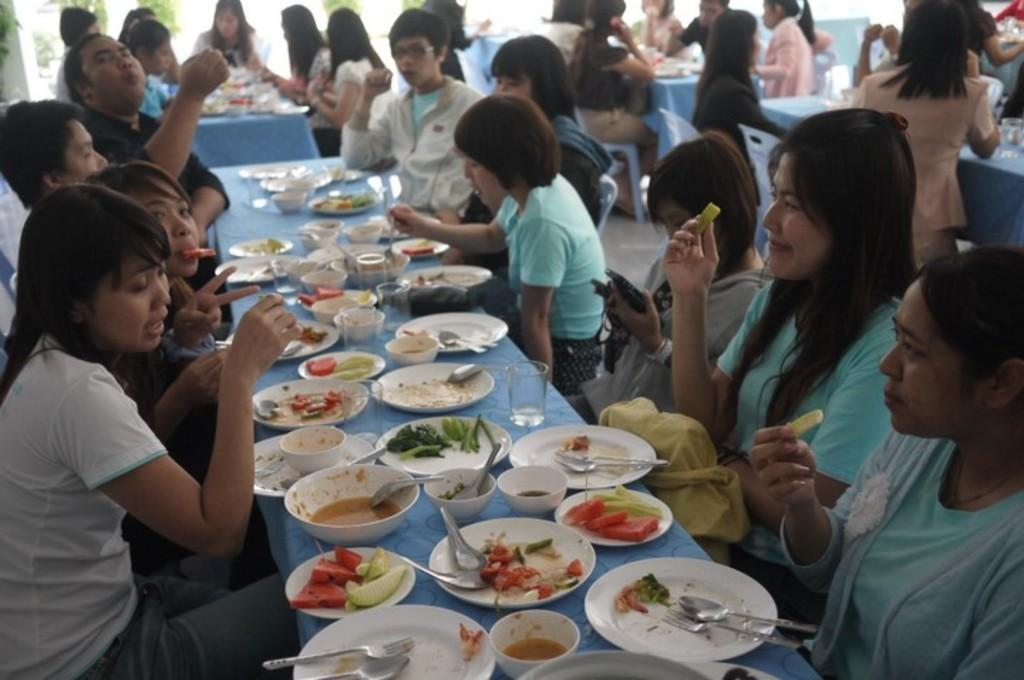How many people are in the image? There is a group of people in the image. What are the people doing in the image? The people are sitting on chairs. What can be observed about the people's clothing? The people are wearing different color dresses. What items can be seen on the table? There are plates, spoons, food items, and bowls in the image. What type of meat is being served by the doctor in the image? There is no doctor or meat present in the image. Can you describe the volleyball game happening in the background of the image? There is no volleyball game or background visible in the image; it only shows a group of people sitting on chairs with items on the table. 